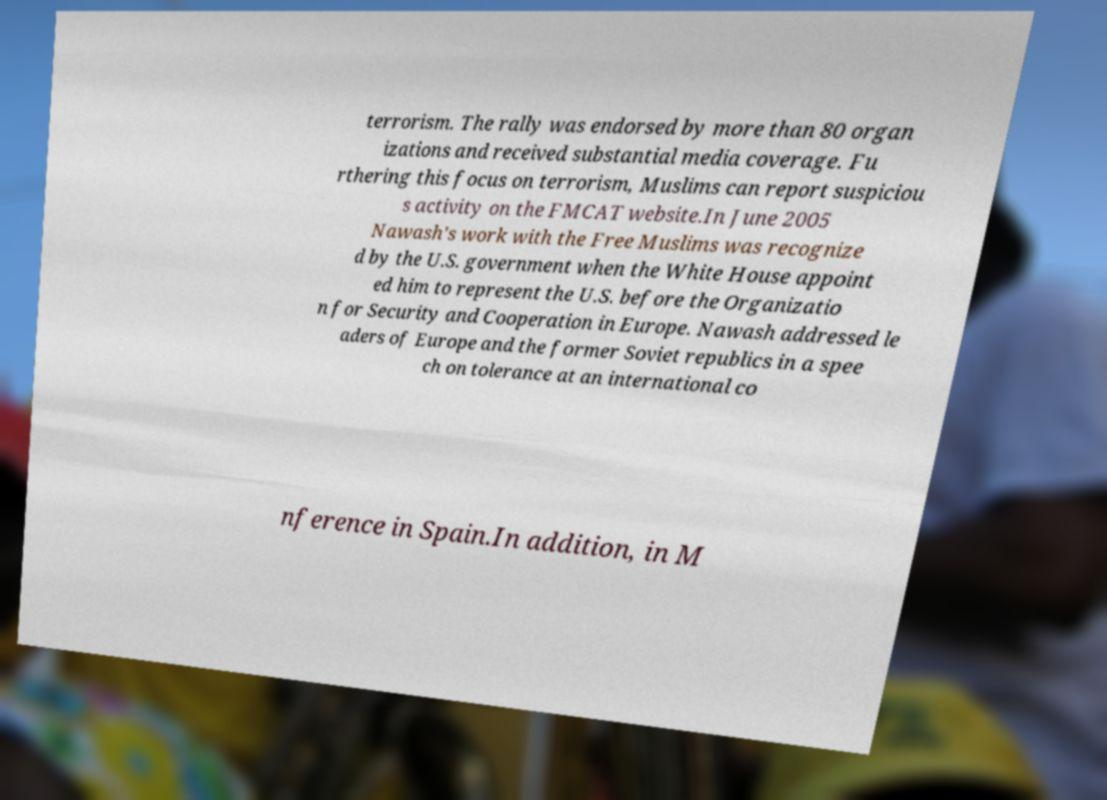Can you accurately transcribe the text from the provided image for me? terrorism. The rally was endorsed by more than 80 organ izations and received substantial media coverage. Fu rthering this focus on terrorism, Muslims can report suspiciou s activity on the FMCAT website.In June 2005 Nawash's work with the Free Muslims was recognize d by the U.S. government when the White House appoint ed him to represent the U.S. before the Organizatio n for Security and Cooperation in Europe. Nawash addressed le aders of Europe and the former Soviet republics in a spee ch on tolerance at an international co nference in Spain.In addition, in M 